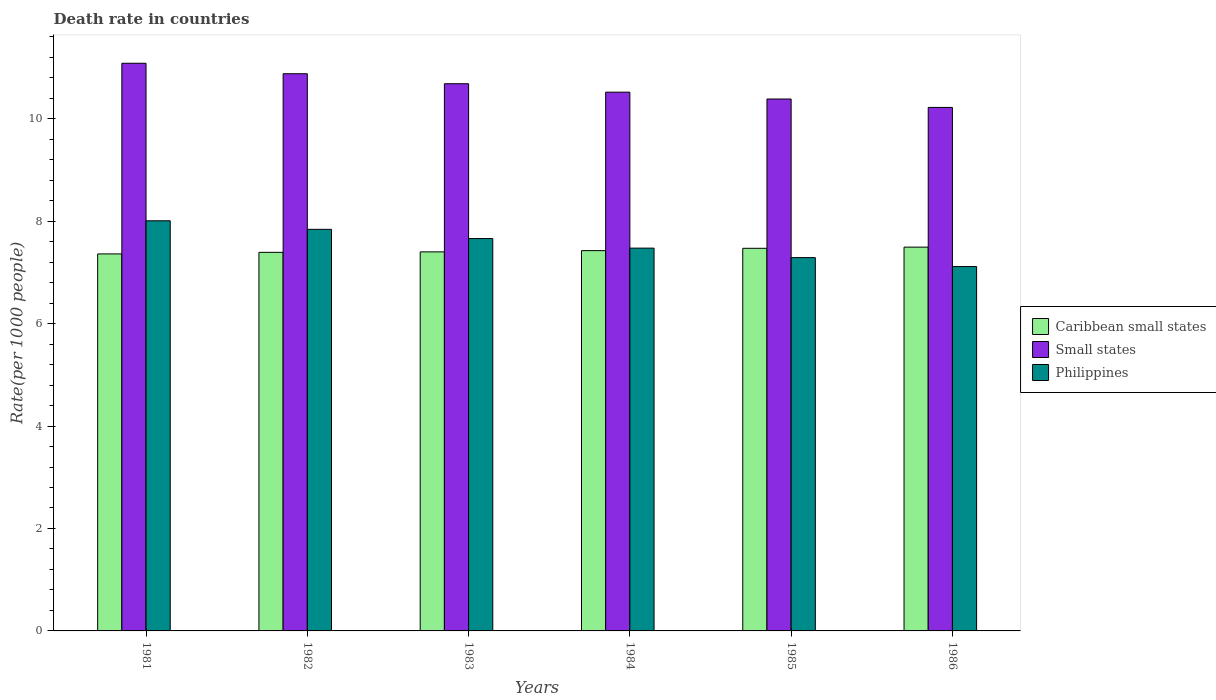How many groups of bars are there?
Keep it short and to the point. 6. Are the number of bars on each tick of the X-axis equal?
Ensure brevity in your answer.  Yes. What is the label of the 1st group of bars from the left?
Offer a terse response. 1981. What is the death rate in Caribbean small states in 1984?
Make the answer very short. 7.42. Across all years, what is the maximum death rate in Caribbean small states?
Give a very brief answer. 7.49. Across all years, what is the minimum death rate in Small states?
Provide a succinct answer. 10.22. In which year was the death rate in Small states maximum?
Provide a short and direct response. 1981. In which year was the death rate in Philippines minimum?
Keep it short and to the point. 1986. What is the total death rate in Philippines in the graph?
Offer a very short reply. 45.38. What is the difference between the death rate in Small states in 1985 and that in 1986?
Provide a succinct answer. 0.16. What is the difference between the death rate in Philippines in 1986 and the death rate in Caribbean small states in 1982?
Provide a short and direct response. -0.28. What is the average death rate in Caribbean small states per year?
Your answer should be very brief. 7.42. In the year 1982, what is the difference between the death rate in Philippines and death rate in Small states?
Keep it short and to the point. -3.04. In how many years, is the death rate in Small states greater than 3.6?
Make the answer very short. 6. What is the ratio of the death rate in Philippines in 1984 to that in 1986?
Provide a succinct answer. 1.05. Is the death rate in Philippines in 1982 less than that in 1984?
Your answer should be compact. No. Is the difference between the death rate in Philippines in 1981 and 1985 greater than the difference between the death rate in Small states in 1981 and 1985?
Give a very brief answer. Yes. What is the difference between the highest and the second highest death rate in Caribbean small states?
Make the answer very short. 0.02. What is the difference between the highest and the lowest death rate in Caribbean small states?
Ensure brevity in your answer.  0.13. In how many years, is the death rate in Caribbean small states greater than the average death rate in Caribbean small states taken over all years?
Keep it short and to the point. 3. Is the sum of the death rate in Philippines in 1982 and 1986 greater than the maximum death rate in Caribbean small states across all years?
Provide a succinct answer. Yes. What does the 1st bar from the left in 1981 represents?
Your answer should be compact. Caribbean small states. What does the 3rd bar from the right in 1984 represents?
Make the answer very short. Caribbean small states. How many bars are there?
Make the answer very short. 18. Are all the bars in the graph horizontal?
Provide a short and direct response. No. Does the graph contain any zero values?
Offer a terse response. No. Does the graph contain grids?
Ensure brevity in your answer.  No. Where does the legend appear in the graph?
Your answer should be very brief. Center right. What is the title of the graph?
Make the answer very short. Death rate in countries. Does "Zimbabwe" appear as one of the legend labels in the graph?
Your response must be concise. No. What is the label or title of the Y-axis?
Provide a succinct answer. Rate(per 1000 people). What is the Rate(per 1000 people) of Caribbean small states in 1981?
Your response must be concise. 7.36. What is the Rate(per 1000 people) of Small states in 1981?
Offer a terse response. 11.08. What is the Rate(per 1000 people) of Philippines in 1981?
Your answer should be compact. 8.01. What is the Rate(per 1000 people) of Caribbean small states in 1982?
Your response must be concise. 7.39. What is the Rate(per 1000 people) in Small states in 1982?
Keep it short and to the point. 10.88. What is the Rate(per 1000 people) of Philippines in 1982?
Offer a terse response. 7.84. What is the Rate(per 1000 people) of Caribbean small states in 1983?
Offer a very short reply. 7.4. What is the Rate(per 1000 people) of Small states in 1983?
Ensure brevity in your answer.  10.68. What is the Rate(per 1000 people) of Philippines in 1983?
Your response must be concise. 7.66. What is the Rate(per 1000 people) in Caribbean small states in 1984?
Your response must be concise. 7.42. What is the Rate(per 1000 people) of Small states in 1984?
Your answer should be compact. 10.52. What is the Rate(per 1000 people) of Philippines in 1984?
Provide a short and direct response. 7.47. What is the Rate(per 1000 people) of Caribbean small states in 1985?
Your answer should be very brief. 7.47. What is the Rate(per 1000 people) in Small states in 1985?
Your answer should be compact. 10.38. What is the Rate(per 1000 people) of Philippines in 1985?
Your answer should be compact. 7.29. What is the Rate(per 1000 people) in Caribbean small states in 1986?
Your answer should be compact. 7.49. What is the Rate(per 1000 people) in Small states in 1986?
Your response must be concise. 10.22. What is the Rate(per 1000 people) in Philippines in 1986?
Give a very brief answer. 7.11. Across all years, what is the maximum Rate(per 1000 people) in Caribbean small states?
Offer a very short reply. 7.49. Across all years, what is the maximum Rate(per 1000 people) in Small states?
Make the answer very short. 11.08. Across all years, what is the maximum Rate(per 1000 people) of Philippines?
Make the answer very short. 8.01. Across all years, what is the minimum Rate(per 1000 people) of Caribbean small states?
Your answer should be compact. 7.36. Across all years, what is the minimum Rate(per 1000 people) in Small states?
Your answer should be very brief. 10.22. Across all years, what is the minimum Rate(per 1000 people) of Philippines?
Your answer should be compact. 7.11. What is the total Rate(per 1000 people) of Caribbean small states in the graph?
Give a very brief answer. 44.54. What is the total Rate(per 1000 people) of Small states in the graph?
Make the answer very short. 63.77. What is the total Rate(per 1000 people) of Philippines in the graph?
Ensure brevity in your answer.  45.38. What is the difference between the Rate(per 1000 people) in Caribbean small states in 1981 and that in 1982?
Give a very brief answer. -0.03. What is the difference between the Rate(per 1000 people) in Small states in 1981 and that in 1982?
Ensure brevity in your answer.  0.2. What is the difference between the Rate(per 1000 people) of Philippines in 1981 and that in 1982?
Make the answer very short. 0.17. What is the difference between the Rate(per 1000 people) of Caribbean small states in 1981 and that in 1983?
Give a very brief answer. -0.04. What is the difference between the Rate(per 1000 people) in Small states in 1981 and that in 1983?
Ensure brevity in your answer.  0.4. What is the difference between the Rate(per 1000 people) in Philippines in 1981 and that in 1983?
Provide a short and direct response. 0.35. What is the difference between the Rate(per 1000 people) of Caribbean small states in 1981 and that in 1984?
Your response must be concise. -0.06. What is the difference between the Rate(per 1000 people) in Small states in 1981 and that in 1984?
Give a very brief answer. 0.56. What is the difference between the Rate(per 1000 people) in Philippines in 1981 and that in 1984?
Offer a terse response. 0.53. What is the difference between the Rate(per 1000 people) in Caribbean small states in 1981 and that in 1985?
Make the answer very short. -0.11. What is the difference between the Rate(per 1000 people) in Small states in 1981 and that in 1985?
Keep it short and to the point. 0.7. What is the difference between the Rate(per 1000 people) of Philippines in 1981 and that in 1985?
Offer a very short reply. 0.72. What is the difference between the Rate(per 1000 people) in Caribbean small states in 1981 and that in 1986?
Provide a short and direct response. -0.13. What is the difference between the Rate(per 1000 people) in Small states in 1981 and that in 1986?
Your answer should be compact. 0.86. What is the difference between the Rate(per 1000 people) in Philippines in 1981 and that in 1986?
Provide a succinct answer. 0.89. What is the difference between the Rate(per 1000 people) in Caribbean small states in 1982 and that in 1983?
Give a very brief answer. -0.01. What is the difference between the Rate(per 1000 people) in Small states in 1982 and that in 1983?
Your answer should be compact. 0.2. What is the difference between the Rate(per 1000 people) in Philippines in 1982 and that in 1983?
Keep it short and to the point. 0.18. What is the difference between the Rate(per 1000 people) of Caribbean small states in 1982 and that in 1984?
Offer a very short reply. -0.03. What is the difference between the Rate(per 1000 people) in Small states in 1982 and that in 1984?
Your response must be concise. 0.36. What is the difference between the Rate(per 1000 people) of Philippines in 1982 and that in 1984?
Your answer should be compact. 0.37. What is the difference between the Rate(per 1000 people) in Caribbean small states in 1982 and that in 1985?
Offer a very short reply. -0.08. What is the difference between the Rate(per 1000 people) in Small states in 1982 and that in 1985?
Give a very brief answer. 0.49. What is the difference between the Rate(per 1000 people) of Philippines in 1982 and that in 1985?
Provide a succinct answer. 0.55. What is the difference between the Rate(per 1000 people) of Caribbean small states in 1982 and that in 1986?
Provide a succinct answer. -0.1. What is the difference between the Rate(per 1000 people) in Small states in 1982 and that in 1986?
Ensure brevity in your answer.  0.66. What is the difference between the Rate(per 1000 people) of Philippines in 1982 and that in 1986?
Your answer should be very brief. 0.73. What is the difference between the Rate(per 1000 people) in Caribbean small states in 1983 and that in 1984?
Offer a terse response. -0.02. What is the difference between the Rate(per 1000 people) in Small states in 1983 and that in 1984?
Make the answer very short. 0.16. What is the difference between the Rate(per 1000 people) of Philippines in 1983 and that in 1984?
Give a very brief answer. 0.19. What is the difference between the Rate(per 1000 people) in Caribbean small states in 1983 and that in 1985?
Offer a terse response. -0.07. What is the difference between the Rate(per 1000 people) of Small states in 1983 and that in 1985?
Make the answer very short. 0.3. What is the difference between the Rate(per 1000 people) of Philippines in 1983 and that in 1985?
Offer a very short reply. 0.37. What is the difference between the Rate(per 1000 people) of Caribbean small states in 1983 and that in 1986?
Ensure brevity in your answer.  -0.09. What is the difference between the Rate(per 1000 people) of Small states in 1983 and that in 1986?
Offer a terse response. 0.46. What is the difference between the Rate(per 1000 people) in Philippines in 1983 and that in 1986?
Offer a terse response. 0.55. What is the difference between the Rate(per 1000 people) in Caribbean small states in 1984 and that in 1985?
Make the answer very short. -0.05. What is the difference between the Rate(per 1000 people) of Small states in 1984 and that in 1985?
Your response must be concise. 0.13. What is the difference between the Rate(per 1000 people) in Philippines in 1984 and that in 1985?
Your response must be concise. 0.18. What is the difference between the Rate(per 1000 people) in Caribbean small states in 1984 and that in 1986?
Keep it short and to the point. -0.07. What is the difference between the Rate(per 1000 people) in Small states in 1984 and that in 1986?
Offer a very short reply. 0.3. What is the difference between the Rate(per 1000 people) of Philippines in 1984 and that in 1986?
Provide a succinct answer. 0.36. What is the difference between the Rate(per 1000 people) of Caribbean small states in 1985 and that in 1986?
Make the answer very short. -0.02. What is the difference between the Rate(per 1000 people) of Small states in 1985 and that in 1986?
Offer a terse response. 0.16. What is the difference between the Rate(per 1000 people) of Philippines in 1985 and that in 1986?
Provide a succinct answer. 0.17. What is the difference between the Rate(per 1000 people) in Caribbean small states in 1981 and the Rate(per 1000 people) in Small states in 1982?
Give a very brief answer. -3.52. What is the difference between the Rate(per 1000 people) in Caribbean small states in 1981 and the Rate(per 1000 people) in Philippines in 1982?
Give a very brief answer. -0.48. What is the difference between the Rate(per 1000 people) in Small states in 1981 and the Rate(per 1000 people) in Philippines in 1982?
Offer a very short reply. 3.24. What is the difference between the Rate(per 1000 people) in Caribbean small states in 1981 and the Rate(per 1000 people) in Small states in 1983?
Keep it short and to the point. -3.32. What is the difference between the Rate(per 1000 people) in Caribbean small states in 1981 and the Rate(per 1000 people) in Philippines in 1983?
Provide a short and direct response. -0.3. What is the difference between the Rate(per 1000 people) in Small states in 1981 and the Rate(per 1000 people) in Philippines in 1983?
Provide a succinct answer. 3.42. What is the difference between the Rate(per 1000 people) of Caribbean small states in 1981 and the Rate(per 1000 people) of Small states in 1984?
Offer a very short reply. -3.16. What is the difference between the Rate(per 1000 people) of Caribbean small states in 1981 and the Rate(per 1000 people) of Philippines in 1984?
Your response must be concise. -0.11. What is the difference between the Rate(per 1000 people) in Small states in 1981 and the Rate(per 1000 people) in Philippines in 1984?
Keep it short and to the point. 3.61. What is the difference between the Rate(per 1000 people) of Caribbean small states in 1981 and the Rate(per 1000 people) of Small states in 1985?
Your response must be concise. -3.02. What is the difference between the Rate(per 1000 people) of Caribbean small states in 1981 and the Rate(per 1000 people) of Philippines in 1985?
Your response must be concise. 0.07. What is the difference between the Rate(per 1000 people) of Small states in 1981 and the Rate(per 1000 people) of Philippines in 1985?
Keep it short and to the point. 3.79. What is the difference between the Rate(per 1000 people) in Caribbean small states in 1981 and the Rate(per 1000 people) in Small states in 1986?
Your response must be concise. -2.86. What is the difference between the Rate(per 1000 people) in Caribbean small states in 1981 and the Rate(per 1000 people) in Philippines in 1986?
Provide a succinct answer. 0.25. What is the difference between the Rate(per 1000 people) of Small states in 1981 and the Rate(per 1000 people) of Philippines in 1986?
Make the answer very short. 3.97. What is the difference between the Rate(per 1000 people) of Caribbean small states in 1982 and the Rate(per 1000 people) of Small states in 1983?
Give a very brief answer. -3.29. What is the difference between the Rate(per 1000 people) of Caribbean small states in 1982 and the Rate(per 1000 people) of Philippines in 1983?
Keep it short and to the point. -0.27. What is the difference between the Rate(per 1000 people) of Small states in 1982 and the Rate(per 1000 people) of Philippines in 1983?
Offer a very short reply. 3.22. What is the difference between the Rate(per 1000 people) in Caribbean small states in 1982 and the Rate(per 1000 people) in Small states in 1984?
Keep it short and to the point. -3.13. What is the difference between the Rate(per 1000 people) of Caribbean small states in 1982 and the Rate(per 1000 people) of Philippines in 1984?
Your answer should be compact. -0.08. What is the difference between the Rate(per 1000 people) in Small states in 1982 and the Rate(per 1000 people) in Philippines in 1984?
Your response must be concise. 3.4. What is the difference between the Rate(per 1000 people) of Caribbean small states in 1982 and the Rate(per 1000 people) of Small states in 1985?
Ensure brevity in your answer.  -2.99. What is the difference between the Rate(per 1000 people) in Caribbean small states in 1982 and the Rate(per 1000 people) in Philippines in 1985?
Ensure brevity in your answer.  0.1. What is the difference between the Rate(per 1000 people) of Small states in 1982 and the Rate(per 1000 people) of Philippines in 1985?
Provide a succinct answer. 3.59. What is the difference between the Rate(per 1000 people) of Caribbean small states in 1982 and the Rate(per 1000 people) of Small states in 1986?
Offer a terse response. -2.83. What is the difference between the Rate(per 1000 people) in Caribbean small states in 1982 and the Rate(per 1000 people) in Philippines in 1986?
Keep it short and to the point. 0.28. What is the difference between the Rate(per 1000 people) of Small states in 1982 and the Rate(per 1000 people) of Philippines in 1986?
Keep it short and to the point. 3.76. What is the difference between the Rate(per 1000 people) of Caribbean small states in 1983 and the Rate(per 1000 people) of Small states in 1984?
Ensure brevity in your answer.  -3.12. What is the difference between the Rate(per 1000 people) in Caribbean small states in 1983 and the Rate(per 1000 people) in Philippines in 1984?
Make the answer very short. -0.07. What is the difference between the Rate(per 1000 people) in Small states in 1983 and the Rate(per 1000 people) in Philippines in 1984?
Provide a succinct answer. 3.21. What is the difference between the Rate(per 1000 people) in Caribbean small states in 1983 and the Rate(per 1000 people) in Small states in 1985?
Provide a short and direct response. -2.98. What is the difference between the Rate(per 1000 people) of Caribbean small states in 1983 and the Rate(per 1000 people) of Philippines in 1985?
Offer a very short reply. 0.11. What is the difference between the Rate(per 1000 people) in Small states in 1983 and the Rate(per 1000 people) in Philippines in 1985?
Offer a terse response. 3.39. What is the difference between the Rate(per 1000 people) in Caribbean small states in 1983 and the Rate(per 1000 people) in Small states in 1986?
Offer a very short reply. -2.82. What is the difference between the Rate(per 1000 people) in Caribbean small states in 1983 and the Rate(per 1000 people) in Philippines in 1986?
Make the answer very short. 0.29. What is the difference between the Rate(per 1000 people) of Small states in 1983 and the Rate(per 1000 people) of Philippines in 1986?
Your response must be concise. 3.57. What is the difference between the Rate(per 1000 people) of Caribbean small states in 1984 and the Rate(per 1000 people) of Small states in 1985?
Ensure brevity in your answer.  -2.96. What is the difference between the Rate(per 1000 people) of Caribbean small states in 1984 and the Rate(per 1000 people) of Philippines in 1985?
Your response must be concise. 0.14. What is the difference between the Rate(per 1000 people) in Small states in 1984 and the Rate(per 1000 people) in Philippines in 1985?
Your response must be concise. 3.23. What is the difference between the Rate(per 1000 people) in Caribbean small states in 1984 and the Rate(per 1000 people) in Small states in 1986?
Your response must be concise. -2.8. What is the difference between the Rate(per 1000 people) of Caribbean small states in 1984 and the Rate(per 1000 people) of Philippines in 1986?
Keep it short and to the point. 0.31. What is the difference between the Rate(per 1000 people) in Small states in 1984 and the Rate(per 1000 people) in Philippines in 1986?
Make the answer very short. 3.4. What is the difference between the Rate(per 1000 people) of Caribbean small states in 1985 and the Rate(per 1000 people) of Small states in 1986?
Your answer should be very brief. -2.75. What is the difference between the Rate(per 1000 people) in Caribbean small states in 1985 and the Rate(per 1000 people) in Philippines in 1986?
Your answer should be very brief. 0.36. What is the difference between the Rate(per 1000 people) in Small states in 1985 and the Rate(per 1000 people) in Philippines in 1986?
Your response must be concise. 3.27. What is the average Rate(per 1000 people) of Caribbean small states per year?
Your response must be concise. 7.42. What is the average Rate(per 1000 people) in Small states per year?
Provide a succinct answer. 10.63. What is the average Rate(per 1000 people) in Philippines per year?
Offer a very short reply. 7.56. In the year 1981, what is the difference between the Rate(per 1000 people) of Caribbean small states and Rate(per 1000 people) of Small states?
Make the answer very short. -3.72. In the year 1981, what is the difference between the Rate(per 1000 people) of Caribbean small states and Rate(per 1000 people) of Philippines?
Provide a succinct answer. -0.65. In the year 1981, what is the difference between the Rate(per 1000 people) of Small states and Rate(per 1000 people) of Philippines?
Keep it short and to the point. 3.08. In the year 1982, what is the difference between the Rate(per 1000 people) of Caribbean small states and Rate(per 1000 people) of Small states?
Keep it short and to the point. -3.49. In the year 1982, what is the difference between the Rate(per 1000 people) of Caribbean small states and Rate(per 1000 people) of Philippines?
Make the answer very short. -0.45. In the year 1982, what is the difference between the Rate(per 1000 people) of Small states and Rate(per 1000 people) of Philippines?
Your answer should be compact. 3.04. In the year 1983, what is the difference between the Rate(per 1000 people) of Caribbean small states and Rate(per 1000 people) of Small states?
Make the answer very short. -3.28. In the year 1983, what is the difference between the Rate(per 1000 people) of Caribbean small states and Rate(per 1000 people) of Philippines?
Your answer should be very brief. -0.26. In the year 1983, what is the difference between the Rate(per 1000 people) in Small states and Rate(per 1000 people) in Philippines?
Make the answer very short. 3.02. In the year 1984, what is the difference between the Rate(per 1000 people) of Caribbean small states and Rate(per 1000 people) of Small states?
Your answer should be compact. -3.09. In the year 1984, what is the difference between the Rate(per 1000 people) of Caribbean small states and Rate(per 1000 people) of Philippines?
Make the answer very short. -0.05. In the year 1984, what is the difference between the Rate(per 1000 people) of Small states and Rate(per 1000 people) of Philippines?
Keep it short and to the point. 3.04. In the year 1985, what is the difference between the Rate(per 1000 people) of Caribbean small states and Rate(per 1000 people) of Small states?
Your answer should be compact. -2.91. In the year 1985, what is the difference between the Rate(per 1000 people) in Caribbean small states and Rate(per 1000 people) in Philippines?
Offer a terse response. 0.18. In the year 1985, what is the difference between the Rate(per 1000 people) in Small states and Rate(per 1000 people) in Philippines?
Give a very brief answer. 3.1. In the year 1986, what is the difference between the Rate(per 1000 people) in Caribbean small states and Rate(per 1000 people) in Small states?
Offer a very short reply. -2.73. In the year 1986, what is the difference between the Rate(per 1000 people) in Caribbean small states and Rate(per 1000 people) in Philippines?
Provide a succinct answer. 0.38. In the year 1986, what is the difference between the Rate(per 1000 people) of Small states and Rate(per 1000 people) of Philippines?
Offer a very short reply. 3.11. What is the ratio of the Rate(per 1000 people) in Small states in 1981 to that in 1982?
Your answer should be compact. 1.02. What is the ratio of the Rate(per 1000 people) of Philippines in 1981 to that in 1982?
Give a very brief answer. 1.02. What is the ratio of the Rate(per 1000 people) of Small states in 1981 to that in 1983?
Offer a very short reply. 1.04. What is the ratio of the Rate(per 1000 people) of Philippines in 1981 to that in 1983?
Offer a terse response. 1.05. What is the ratio of the Rate(per 1000 people) in Caribbean small states in 1981 to that in 1984?
Your response must be concise. 0.99. What is the ratio of the Rate(per 1000 people) in Small states in 1981 to that in 1984?
Keep it short and to the point. 1.05. What is the ratio of the Rate(per 1000 people) of Philippines in 1981 to that in 1984?
Make the answer very short. 1.07. What is the ratio of the Rate(per 1000 people) of Caribbean small states in 1981 to that in 1985?
Provide a short and direct response. 0.99. What is the ratio of the Rate(per 1000 people) in Small states in 1981 to that in 1985?
Keep it short and to the point. 1.07. What is the ratio of the Rate(per 1000 people) of Philippines in 1981 to that in 1985?
Keep it short and to the point. 1.1. What is the ratio of the Rate(per 1000 people) of Caribbean small states in 1981 to that in 1986?
Keep it short and to the point. 0.98. What is the ratio of the Rate(per 1000 people) in Small states in 1981 to that in 1986?
Your answer should be very brief. 1.08. What is the ratio of the Rate(per 1000 people) in Philippines in 1981 to that in 1986?
Keep it short and to the point. 1.13. What is the ratio of the Rate(per 1000 people) of Caribbean small states in 1982 to that in 1983?
Your answer should be compact. 1. What is the ratio of the Rate(per 1000 people) of Small states in 1982 to that in 1983?
Keep it short and to the point. 1.02. What is the ratio of the Rate(per 1000 people) in Philippines in 1982 to that in 1983?
Make the answer very short. 1.02. What is the ratio of the Rate(per 1000 people) in Caribbean small states in 1982 to that in 1984?
Ensure brevity in your answer.  1. What is the ratio of the Rate(per 1000 people) in Small states in 1982 to that in 1984?
Your answer should be compact. 1.03. What is the ratio of the Rate(per 1000 people) of Philippines in 1982 to that in 1984?
Make the answer very short. 1.05. What is the ratio of the Rate(per 1000 people) of Small states in 1982 to that in 1985?
Your response must be concise. 1.05. What is the ratio of the Rate(per 1000 people) in Philippines in 1982 to that in 1985?
Make the answer very short. 1.08. What is the ratio of the Rate(per 1000 people) in Caribbean small states in 1982 to that in 1986?
Give a very brief answer. 0.99. What is the ratio of the Rate(per 1000 people) of Small states in 1982 to that in 1986?
Provide a succinct answer. 1.06. What is the ratio of the Rate(per 1000 people) of Philippines in 1982 to that in 1986?
Your response must be concise. 1.1. What is the ratio of the Rate(per 1000 people) in Caribbean small states in 1983 to that in 1984?
Make the answer very short. 1. What is the ratio of the Rate(per 1000 people) in Small states in 1983 to that in 1984?
Your response must be concise. 1.02. What is the ratio of the Rate(per 1000 people) of Philippines in 1983 to that in 1984?
Your answer should be very brief. 1.02. What is the ratio of the Rate(per 1000 people) in Caribbean small states in 1983 to that in 1985?
Your response must be concise. 0.99. What is the ratio of the Rate(per 1000 people) in Small states in 1983 to that in 1985?
Offer a very short reply. 1.03. What is the ratio of the Rate(per 1000 people) of Philippines in 1983 to that in 1985?
Keep it short and to the point. 1.05. What is the ratio of the Rate(per 1000 people) in Caribbean small states in 1983 to that in 1986?
Offer a very short reply. 0.99. What is the ratio of the Rate(per 1000 people) of Small states in 1983 to that in 1986?
Offer a very short reply. 1.05. What is the ratio of the Rate(per 1000 people) in Philippines in 1983 to that in 1986?
Give a very brief answer. 1.08. What is the ratio of the Rate(per 1000 people) in Caribbean small states in 1984 to that in 1985?
Give a very brief answer. 0.99. What is the ratio of the Rate(per 1000 people) of Small states in 1984 to that in 1985?
Provide a succinct answer. 1.01. What is the ratio of the Rate(per 1000 people) of Philippines in 1984 to that in 1985?
Provide a succinct answer. 1.03. What is the ratio of the Rate(per 1000 people) of Caribbean small states in 1984 to that in 1986?
Your answer should be compact. 0.99. What is the ratio of the Rate(per 1000 people) in Small states in 1984 to that in 1986?
Offer a very short reply. 1.03. What is the ratio of the Rate(per 1000 people) in Philippines in 1984 to that in 1986?
Make the answer very short. 1.05. What is the ratio of the Rate(per 1000 people) of Small states in 1985 to that in 1986?
Ensure brevity in your answer.  1.02. What is the ratio of the Rate(per 1000 people) of Philippines in 1985 to that in 1986?
Ensure brevity in your answer.  1.02. What is the difference between the highest and the second highest Rate(per 1000 people) in Caribbean small states?
Provide a short and direct response. 0.02. What is the difference between the highest and the second highest Rate(per 1000 people) in Small states?
Your answer should be compact. 0.2. What is the difference between the highest and the second highest Rate(per 1000 people) in Philippines?
Make the answer very short. 0.17. What is the difference between the highest and the lowest Rate(per 1000 people) in Caribbean small states?
Ensure brevity in your answer.  0.13. What is the difference between the highest and the lowest Rate(per 1000 people) of Small states?
Provide a short and direct response. 0.86. What is the difference between the highest and the lowest Rate(per 1000 people) in Philippines?
Your answer should be compact. 0.89. 